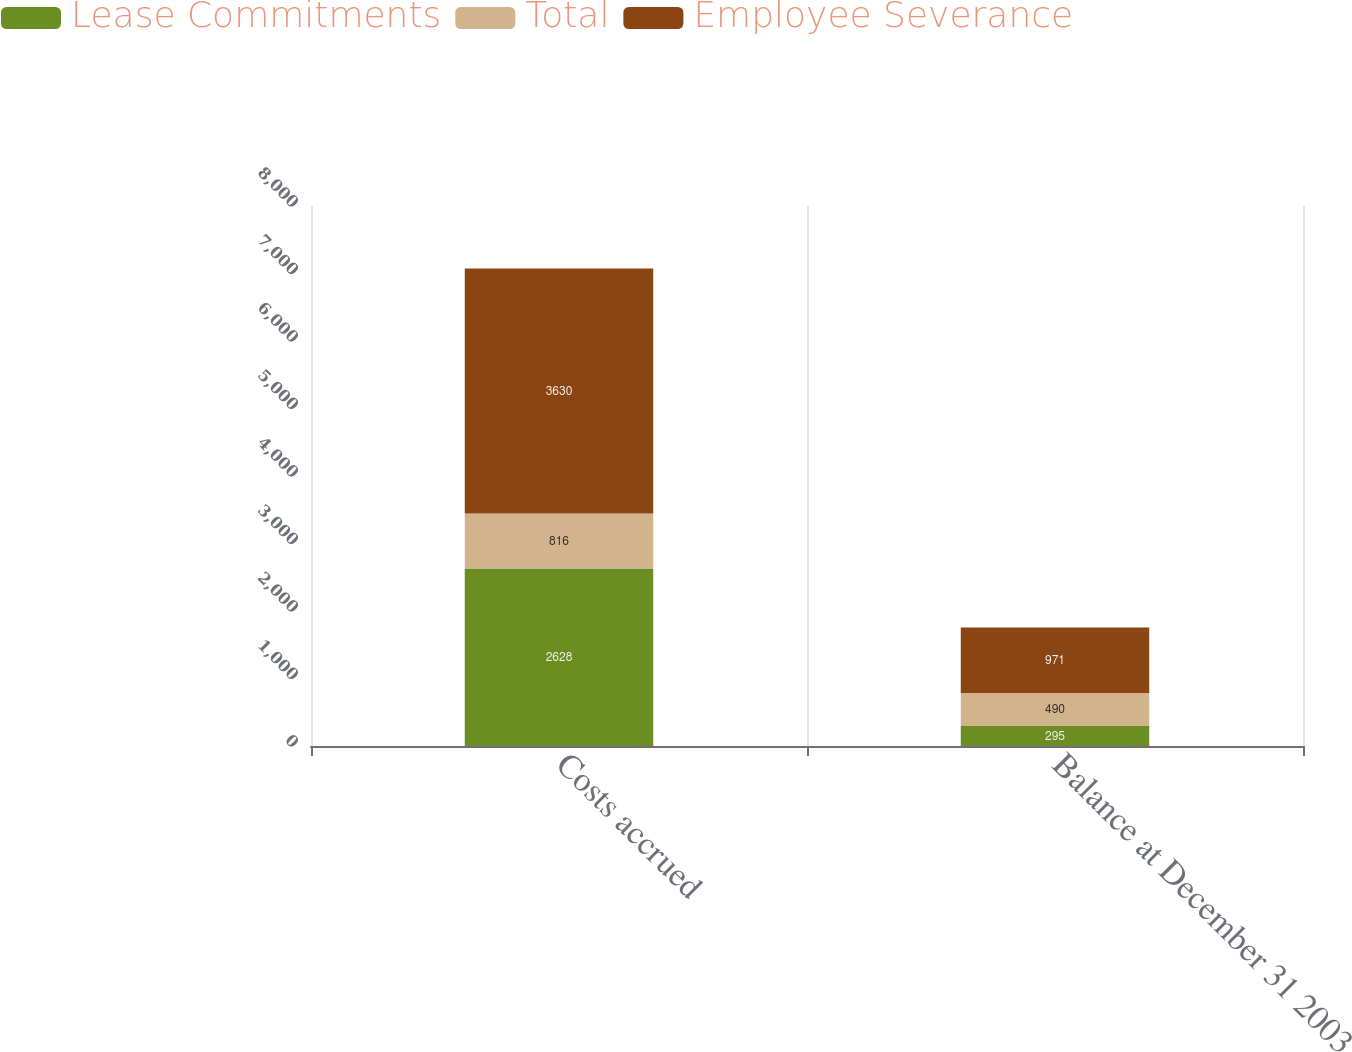Convert chart to OTSL. <chart><loc_0><loc_0><loc_500><loc_500><stacked_bar_chart><ecel><fcel>Costs accrued<fcel>Balance at December 31 2003<nl><fcel>Lease Commitments<fcel>2628<fcel>295<nl><fcel>Total<fcel>816<fcel>490<nl><fcel>Employee Severance<fcel>3630<fcel>971<nl></chart> 